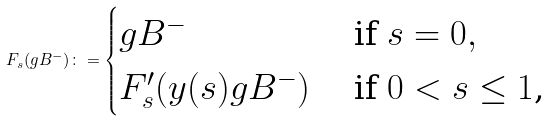<formula> <loc_0><loc_0><loc_500><loc_500>F _ { s } ( g B ^ { - } ) \colon = \begin{cases} g B ^ { - } & \text { if $s=0$} , \\ F ^ { \prime } _ { s } ( y ( s ) g B ^ { - } ) & \text { if $0<s\leq 1$,} \end{cases}</formula> 